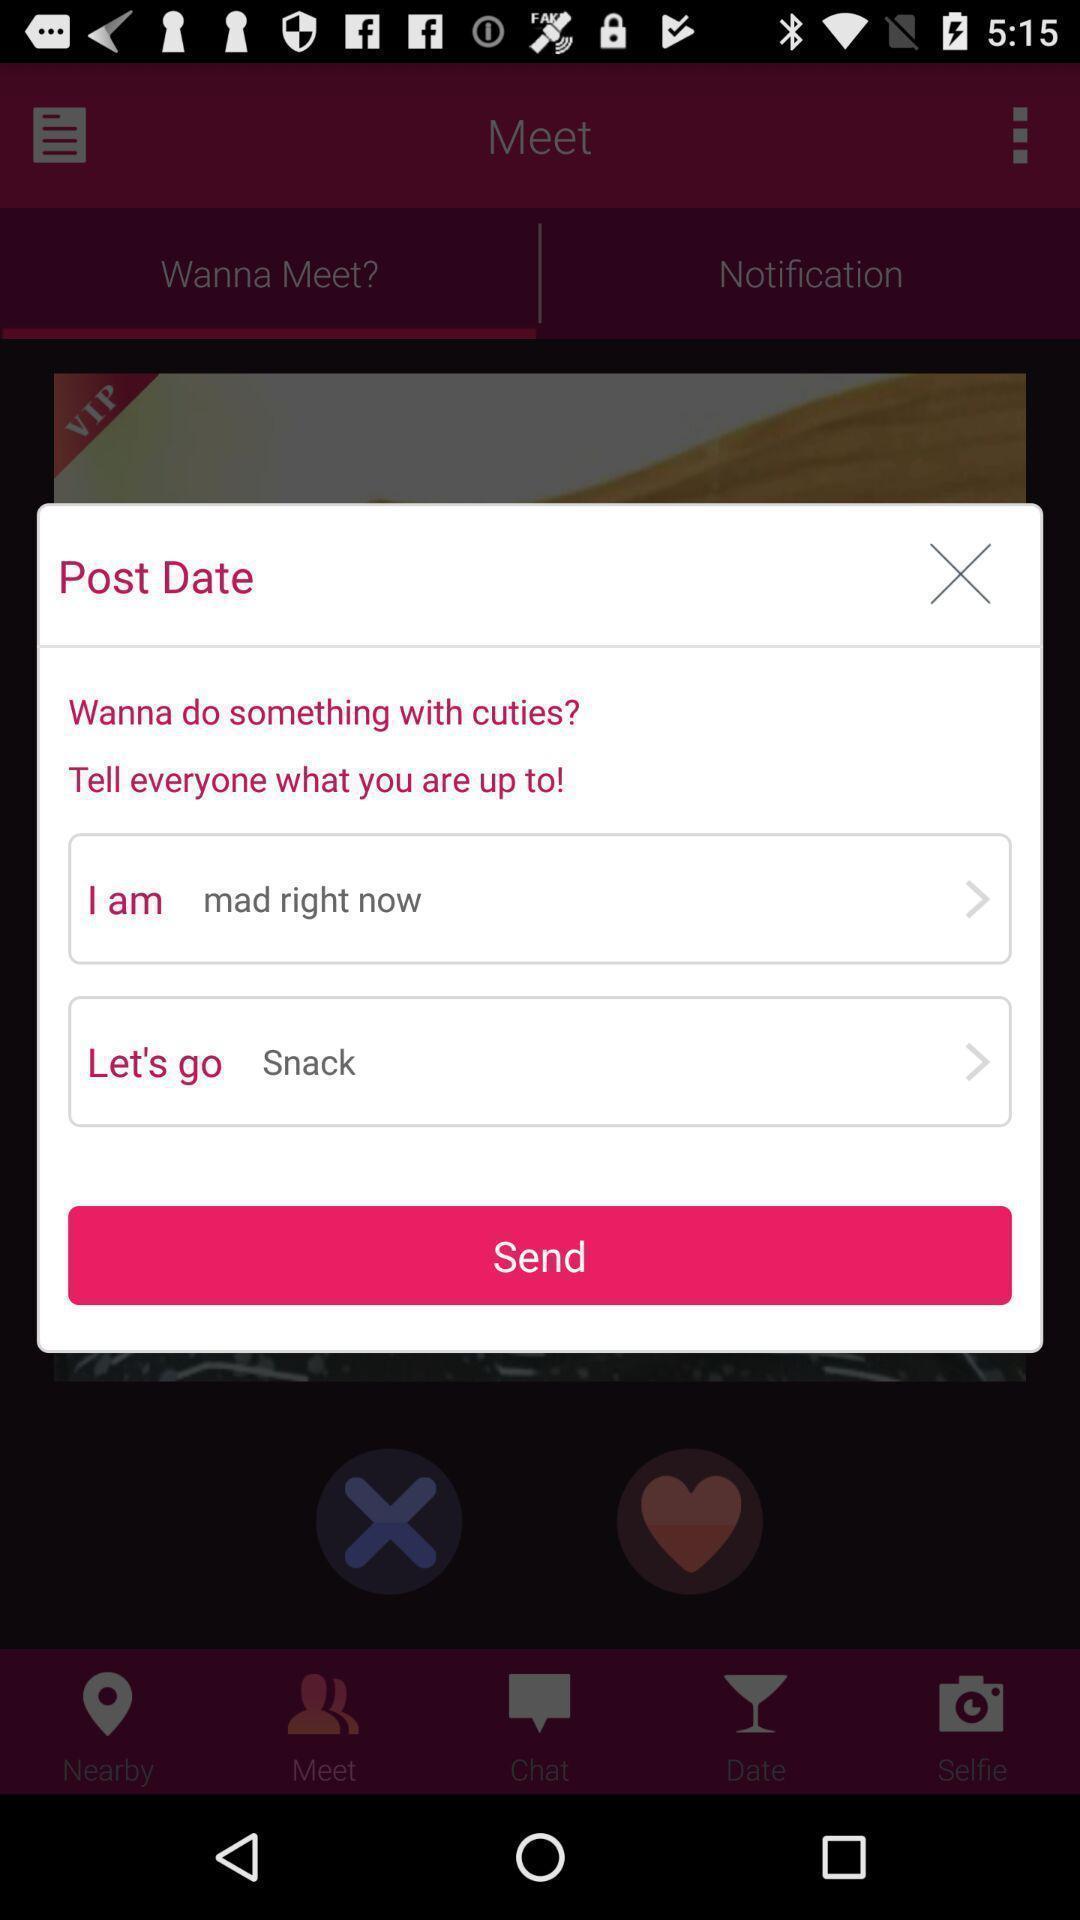Describe this image in words. Pop up showing post to send. 